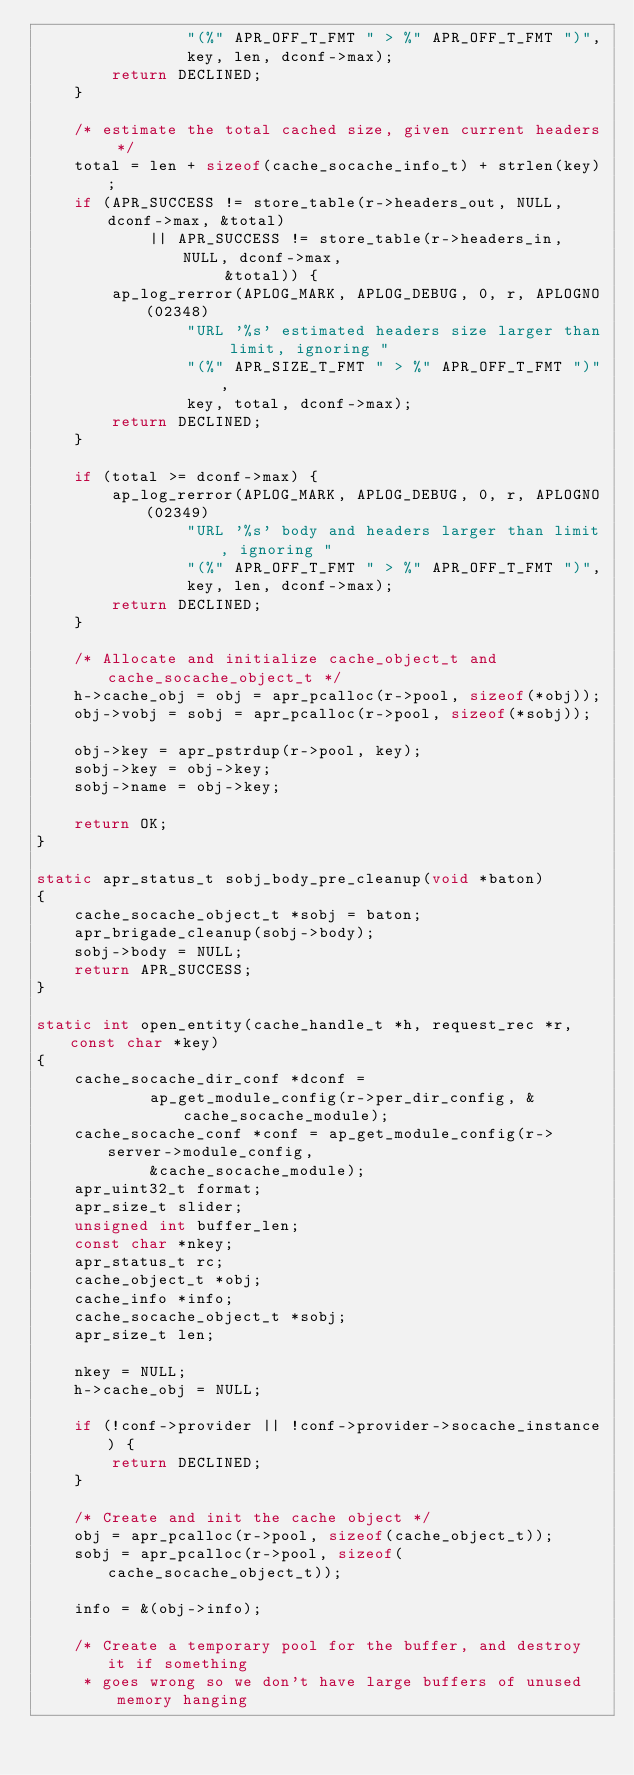Convert code to text. <code><loc_0><loc_0><loc_500><loc_500><_C_>                "(%" APR_OFF_T_FMT " > %" APR_OFF_T_FMT ")",
                key, len, dconf->max);
        return DECLINED;
    }

    /* estimate the total cached size, given current headers */
    total = len + sizeof(cache_socache_info_t) + strlen(key);
    if (APR_SUCCESS != store_table(r->headers_out, NULL, dconf->max, &total)
            || APR_SUCCESS != store_table(r->headers_in, NULL, dconf->max,
                    &total)) {
        ap_log_rerror(APLOG_MARK, APLOG_DEBUG, 0, r, APLOGNO(02348)
                "URL '%s' estimated headers size larger than limit, ignoring "
                "(%" APR_SIZE_T_FMT " > %" APR_OFF_T_FMT ")",
                key, total, dconf->max);
        return DECLINED;
    }

    if (total >= dconf->max) {
        ap_log_rerror(APLOG_MARK, APLOG_DEBUG, 0, r, APLOGNO(02349)
                "URL '%s' body and headers larger than limit, ignoring "
                "(%" APR_OFF_T_FMT " > %" APR_OFF_T_FMT ")",
                key, len, dconf->max);
        return DECLINED;
    }

    /* Allocate and initialize cache_object_t and cache_socache_object_t */
    h->cache_obj = obj = apr_pcalloc(r->pool, sizeof(*obj));
    obj->vobj = sobj = apr_pcalloc(r->pool, sizeof(*sobj));

    obj->key = apr_pstrdup(r->pool, key);
    sobj->key = obj->key;
    sobj->name = obj->key;

    return OK;
}

static apr_status_t sobj_body_pre_cleanup(void *baton)
{
    cache_socache_object_t *sobj = baton;
    apr_brigade_cleanup(sobj->body);
    sobj->body = NULL;
    return APR_SUCCESS;
}

static int open_entity(cache_handle_t *h, request_rec *r, const char *key)
{
    cache_socache_dir_conf *dconf =
            ap_get_module_config(r->per_dir_config, &cache_socache_module);
    cache_socache_conf *conf = ap_get_module_config(r->server->module_config,
            &cache_socache_module);
    apr_uint32_t format;
    apr_size_t slider;
    unsigned int buffer_len;
    const char *nkey;
    apr_status_t rc;
    cache_object_t *obj;
    cache_info *info;
    cache_socache_object_t *sobj;
    apr_size_t len;

    nkey = NULL;
    h->cache_obj = NULL;

    if (!conf->provider || !conf->provider->socache_instance) {
        return DECLINED;
    }

    /* Create and init the cache object */
    obj = apr_pcalloc(r->pool, sizeof(cache_object_t));
    sobj = apr_pcalloc(r->pool, sizeof(cache_socache_object_t));

    info = &(obj->info);

    /* Create a temporary pool for the buffer, and destroy it if something
     * goes wrong so we don't have large buffers of unused memory hanging</code> 